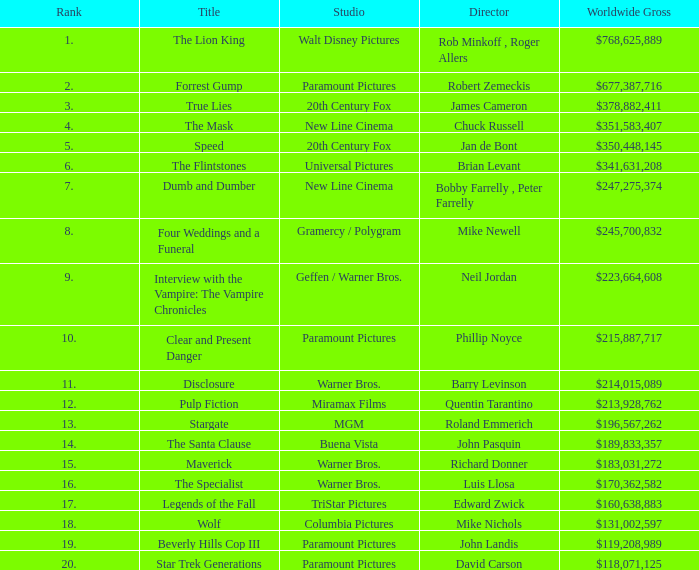Help me parse the entirety of this table. {'header': ['Rank', 'Title', 'Studio', 'Director', 'Worldwide Gross'], 'rows': [['1.', 'The Lion King', 'Walt Disney Pictures', 'Rob Minkoff , Roger Allers', '$768,625,889'], ['2.', 'Forrest Gump', 'Paramount Pictures', 'Robert Zemeckis', '$677,387,716'], ['3.', 'True Lies', '20th Century Fox', 'James Cameron', '$378,882,411'], ['4.', 'The Mask', 'New Line Cinema', 'Chuck Russell', '$351,583,407'], ['5.', 'Speed', '20th Century Fox', 'Jan de Bont', '$350,448,145'], ['6.', 'The Flintstones', 'Universal Pictures', 'Brian Levant', '$341,631,208'], ['7.', 'Dumb and Dumber', 'New Line Cinema', 'Bobby Farrelly , Peter Farrelly', '$247,275,374'], ['8.', 'Four Weddings and a Funeral', 'Gramercy / Polygram', 'Mike Newell', '$245,700,832'], ['9.', 'Interview with the Vampire: The Vampire Chronicles', 'Geffen / Warner Bros.', 'Neil Jordan', '$223,664,608'], ['10.', 'Clear and Present Danger', 'Paramount Pictures', 'Phillip Noyce', '$215,887,717'], ['11.', 'Disclosure', 'Warner Bros.', 'Barry Levinson', '$214,015,089'], ['12.', 'Pulp Fiction', 'Miramax Films', 'Quentin Tarantino', '$213,928,762'], ['13.', 'Stargate', 'MGM', 'Roland Emmerich', '$196,567,262'], ['14.', 'The Santa Clause', 'Buena Vista', 'John Pasquin', '$189,833,357'], ['15.', 'Maverick', 'Warner Bros.', 'Richard Donner', '$183,031,272'], ['16.', 'The Specialist', 'Warner Bros.', 'Luis Llosa', '$170,362,582'], ['17.', 'Legends of the Fall', 'TriStar Pictures', 'Edward Zwick', '$160,638,883'], ['18.', 'Wolf', 'Columbia Pictures', 'Mike Nichols', '$131,002,597'], ['19.', 'Beverly Hills Cop III', 'Paramount Pictures', 'John Landis', '$119,208,989'], ['20.', 'Star Trek Generations', 'Paramount Pictures', 'David Carson', '$118,071,125']]} What is the Worldwide Gross of the Film with a Rank of 16? $170,362,582. 